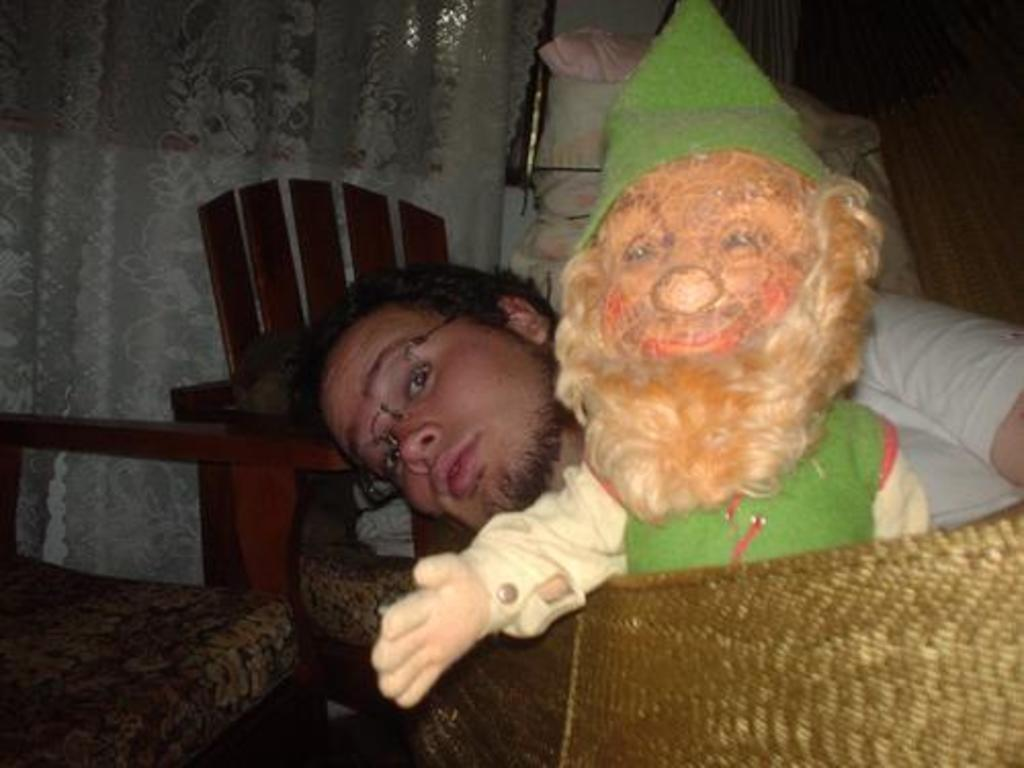Who is present in the image? There is a man in the image. What other object is present in the image? There is a doll in the image. Where are the man and doll located in the image? The man and doll are in the middle of the image. What can be seen on the left side of the image? There is a chair on the left side of the image. What color is the curtain visible in the background of the image? There is a white color curtain in the background of the image. How does the wind affect the man and doll in the image? There is no wind present in the image, so its effect cannot be determined. What type of glue is being used by the man in the image? There is no glue present in the image, and the man is not shown using any glue. 